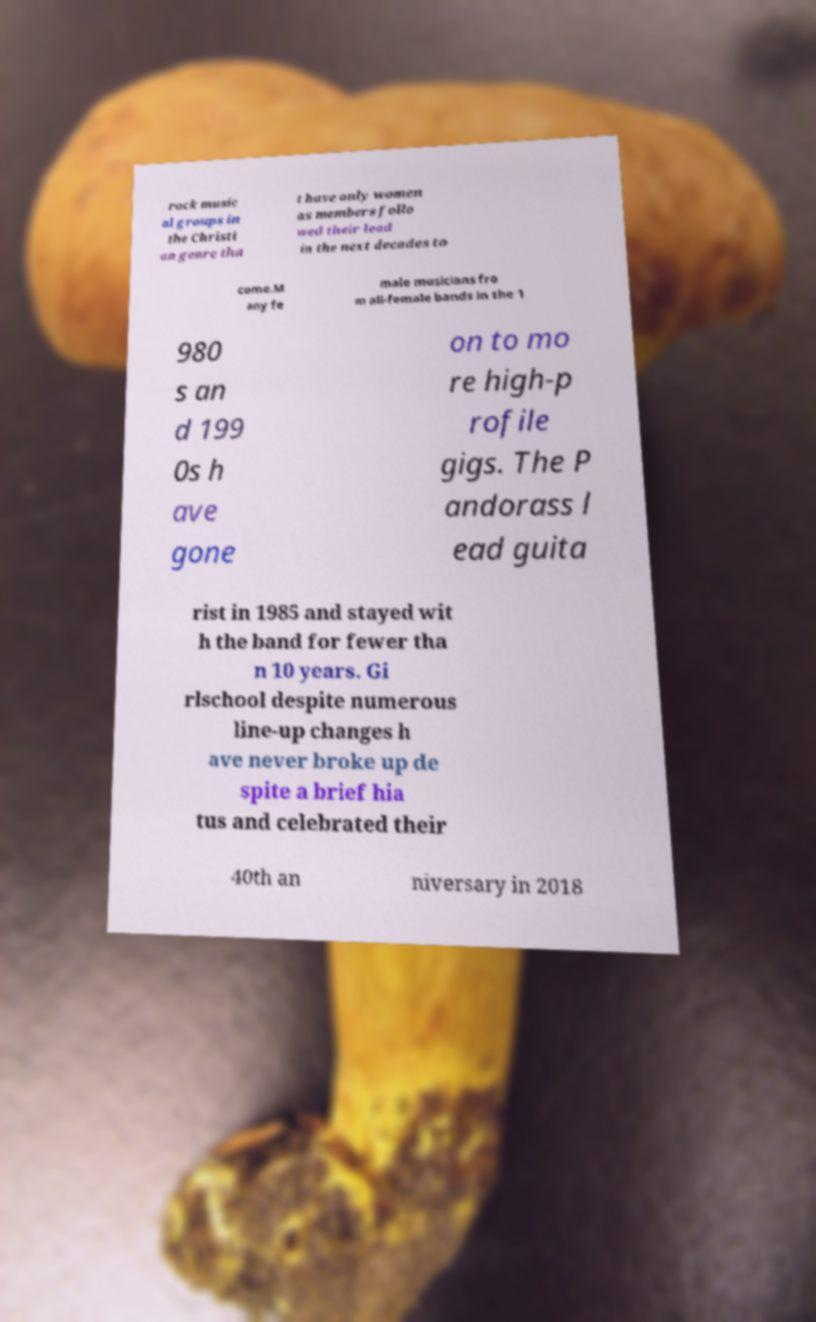I need the written content from this picture converted into text. Can you do that? rock music al groups in the Christi an genre tha t have only women as members follo wed their lead in the next decades to come.M any fe male musicians fro m all-female bands in the 1 980 s an d 199 0s h ave gone on to mo re high-p rofile gigs. The P andorass l ead guita rist in 1985 and stayed wit h the band for fewer tha n 10 years. Gi rlschool despite numerous line-up changes h ave never broke up de spite a brief hia tus and celebrated their 40th an niversary in 2018 